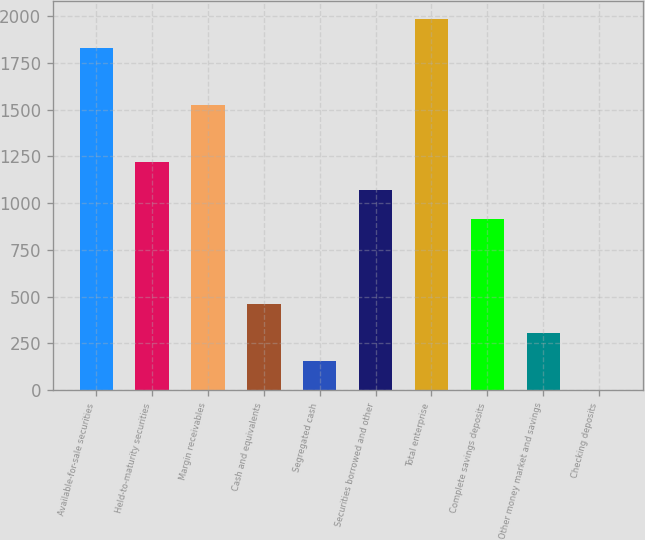Convert chart to OTSL. <chart><loc_0><loc_0><loc_500><loc_500><bar_chart><fcel>Available-for-sale securities<fcel>Held-to-maturity securities<fcel>Margin receivables<fcel>Cash and equivalents<fcel>Segregated cash<fcel>Securities borrowed and other<fcel>Total enterprise<fcel>Complete savings deposits<fcel>Other money market and savings<fcel>Checking deposits<nl><fcel>1831.16<fcel>1221.04<fcel>1526.1<fcel>458.39<fcel>153.33<fcel>1068.51<fcel>1983.69<fcel>915.98<fcel>305.86<fcel>0.8<nl></chart> 